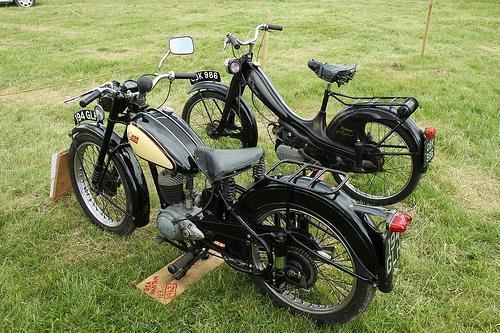How many bikes are there?
Give a very brief answer. 2. How many people are visible?
Give a very brief answer. 0. 